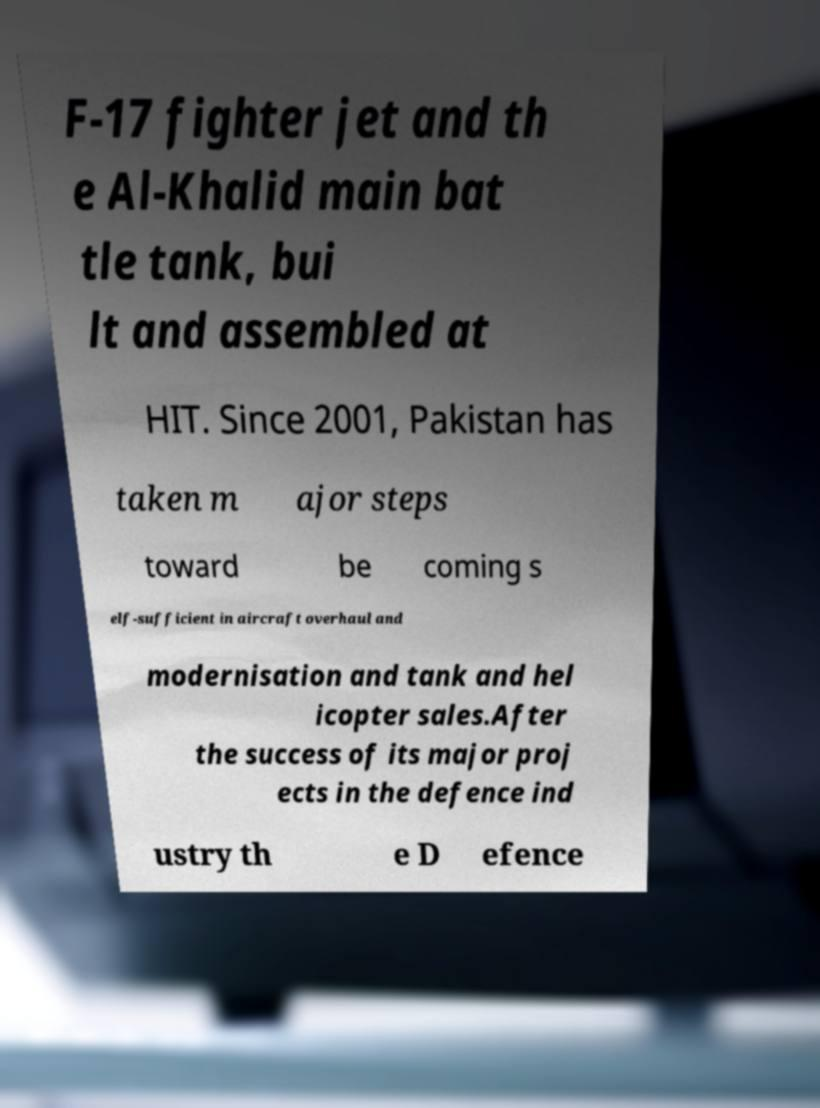Please read and relay the text visible in this image. What does it say? F-17 fighter jet and th e Al-Khalid main bat tle tank, bui lt and assembled at HIT. Since 2001, Pakistan has taken m ajor steps toward be coming s elf-sufficient in aircraft overhaul and modernisation and tank and hel icopter sales.After the success of its major proj ects in the defence ind ustry th e D efence 